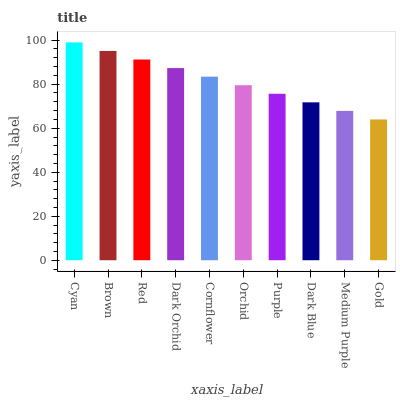Is Gold the minimum?
Answer yes or no. Yes. Is Cyan the maximum?
Answer yes or no. Yes. Is Brown the minimum?
Answer yes or no. No. Is Brown the maximum?
Answer yes or no. No. Is Cyan greater than Brown?
Answer yes or no. Yes. Is Brown less than Cyan?
Answer yes or no. Yes. Is Brown greater than Cyan?
Answer yes or no. No. Is Cyan less than Brown?
Answer yes or no. No. Is Cornflower the high median?
Answer yes or no. Yes. Is Orchid the low median?
Answer yes or no. Yes. Is Purple the high median?
Answer yes or no. No. Is Purple the low median?
Answer yes or no. No. 